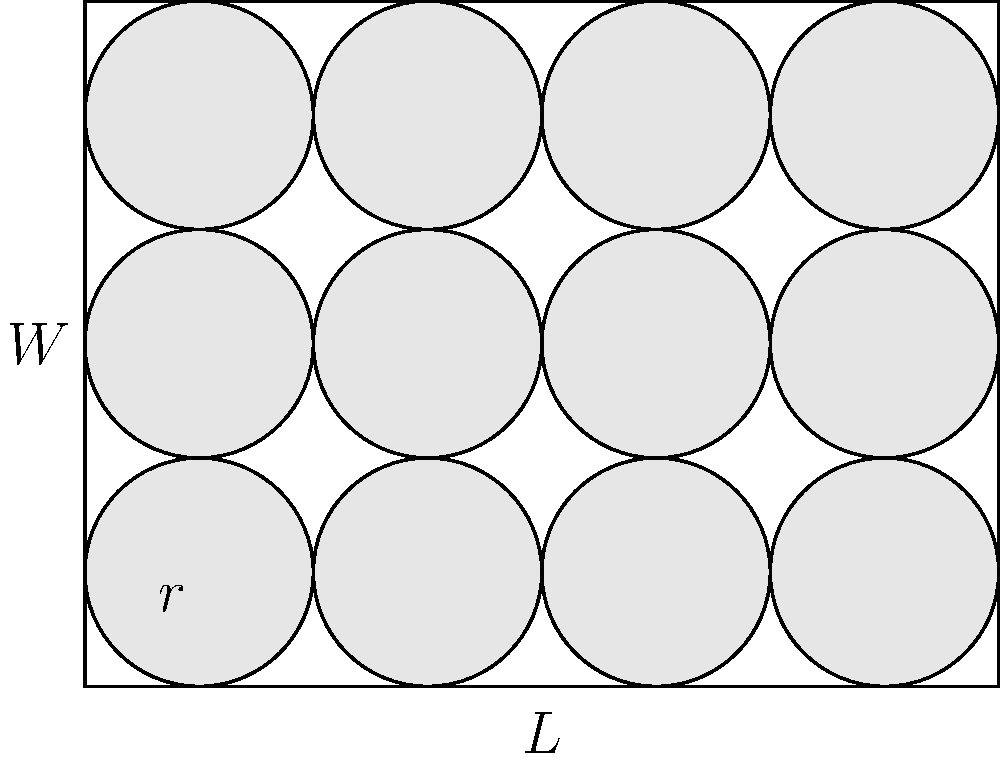In a humanitarian aid project, you need to optimize the packing of cylindrical food containers in rectangular shipping boxes. Given a box with length $L = 4$ units and width $W = 3$ units, and cylindrical containers with radius $r = 0.5$ units, what is the maximum number of containers that can be packed in a single layer within the box? To solve this problem, we'll follow these steps:

1) First, we need to determine how many containers can fit along the length and width of the box.

2) For the length:
   - The diameter of each container is $2r = 1$ unit
   - The number of containers along the length = $\lfloor L / (2r) \rfloor = \lfloor 4 / 1 \rfloor = 4$
   Where $\lfloor \rfloor$ denotes the floor function (rounding down to the nearest integer)

3) For the width:
   - The number of containers along the width = $\lfloor W / (2r) \rfloor = \lfloor 3 / 1 \rfloor = 3$

4) The total number of containers is the product of the number along the length and width:
   $4 \times 3 = 12$

5) We can verify this visually in the provided diagram, where we see 4 containers along the length and 3 along the width, totaling 12 containers.

This packing arrangement is optimal for cylindrical containers in a rectangular box, as it maximizes the use of available space while ensuring the containers don't overlap or extend beyond the box dimensions.
Answer: 12 containers 